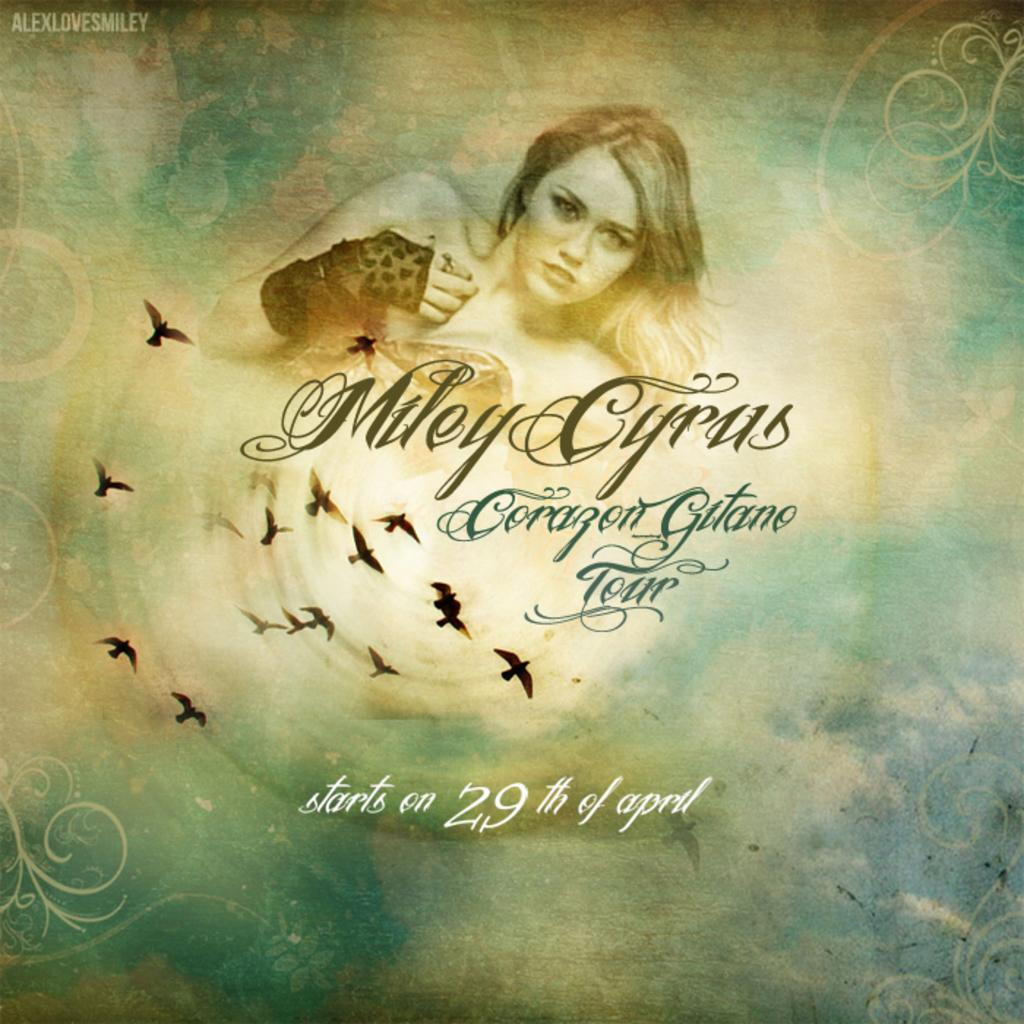<image>
Render a clear and concise summary of the photo. An album cover for a Miley Cyrus album. 